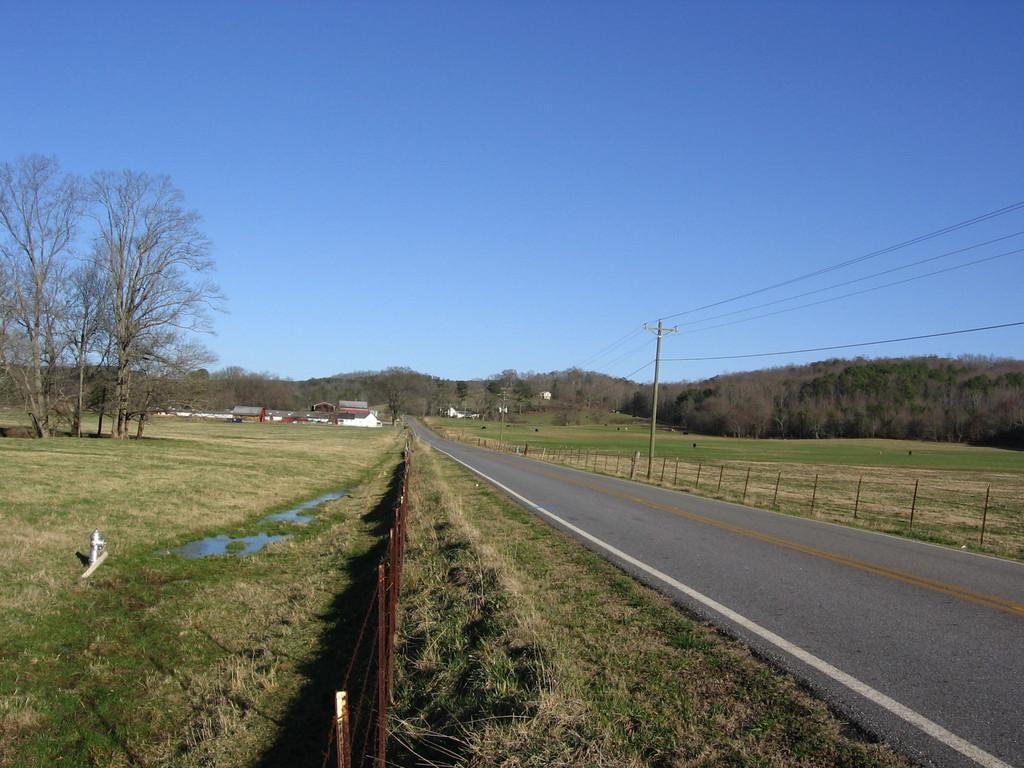What type of vegetation can be seen in the image? There are trees in the image. What type of structures are present in the image? There are houses in the image. What other objects can be seen in the image? There are poles, wires, grass, a fence, a hydrant, and a road in the image. What is visible in the background of the image? The sky is visible in the background of the image. Where is the bell located in the image? There is no bell present in the image. What shape is the square in the image? There is no square present in the image. 